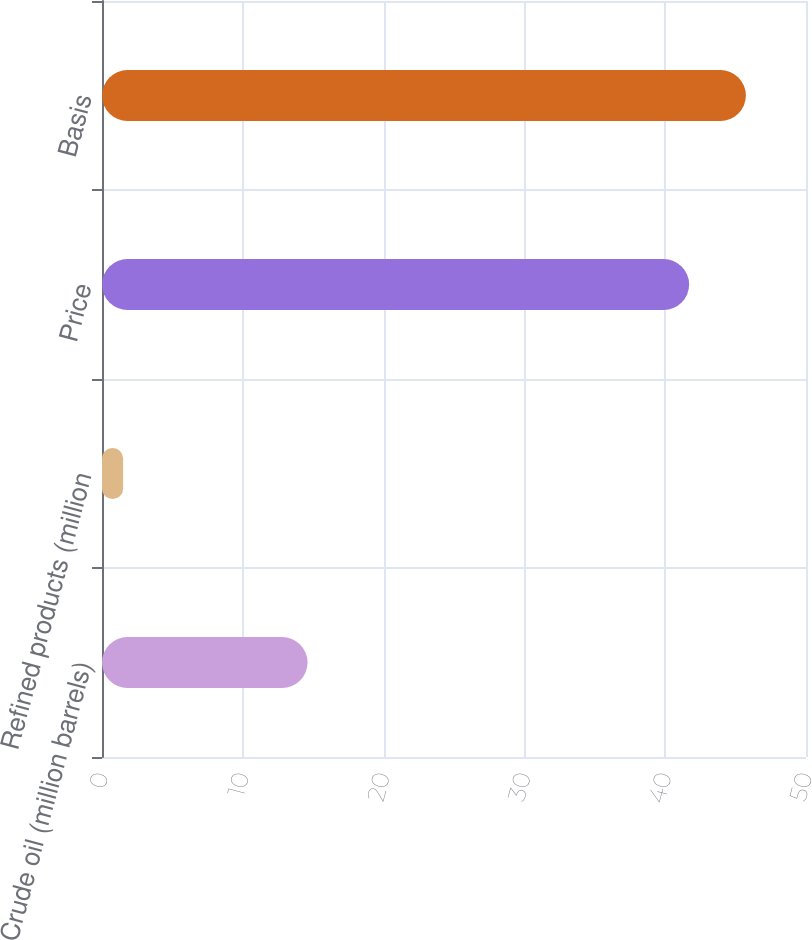Convert chart. <chart><loc_0><loc_0><loc_500><loc_500><bar_chart><fcel>Crude oil (million barrels)<fcel>Refined products (million<fcel>Price<fcel>Basis<nl><fcel>14.6<fcel>1.5<fcel>41.7<fcel>45.73<nl></chart> 